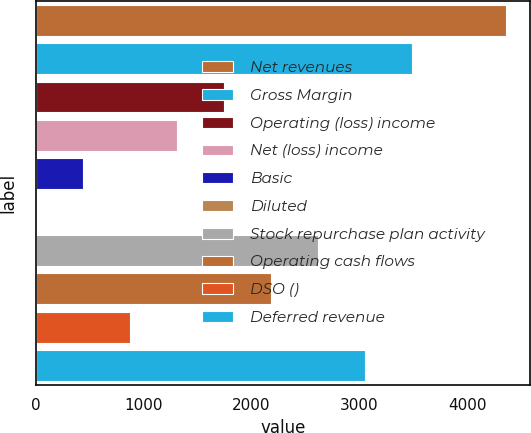<chart> <loc_0><loc_0><loc_500><loc_500><bar_chart><fcel>Net revenues<fcel>Gross Margin<fcel>Operating (loss) income<fcel>Net (loss) income<fcel>Basic<fcel>Diluted<fcel>Stock repurchase plan activity<fcel>Operating cash flows<fcel>DSO ()<fcel>Deferred revenue<nl><fcel>4365.4<fcel>3492.39<fcel>1746.37<fcel>1309.87<fcel>436.85<fcel>0.35<fcel>2619.39<fcel>2182.88<fcel>873.36<fcel>3055.89<nl></chart> 